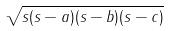<formula> <loc_0><loc_0><loc_500><loc_500>\sqrt { s ( s - a ) ( s - b ) ( s - c ) }</formula> 